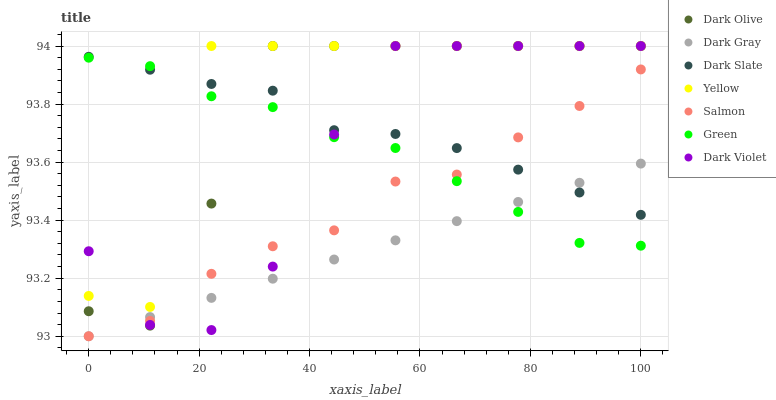Does Dark Gray have the minimum area under the curve?
Answer yes or no. Yes. Does Yellow have the maximum area under the curve?
Answer yes or no. Yes. Does Salmon have the minimum area under the curve?
Answer yes or no. No. Does Salmon have the maximum area under the curve?
Answer yes or no. No. Is Dark Gray the smoothest?
Answer yes or no. Yes. Is Yellow the roughest?
Answer yes or no. Yes. Is Salmon the smoothest?
Answer yes or no. No. Is Salmon the roughest?
Answer yes or no. No. Does Salmon have the lowest value?
Answer yes or no. Yes. Does Yellow have the lowest value?
Answer yes or no. No. Does Dark Violet have the highest value?
Answer yes or no. Yes. Does Salmon have the highest value?
Answer yes or no. No. Is Salmon less than Yellow?
Answer yes or no. Yes. Is Yellow greater than Dark Gray?
Answer yes or no. Yes. Does Dark Violet intersect Dark Slate?
Answer yes or no. Yes. Is Dark Violet less than Dark Slate?
Answer yes or no. No. Is Dark Violet greater than Dark Slate?
Answer yes or no. No. Does Salmon intersect Yellow?
Answer yes or no. No. 